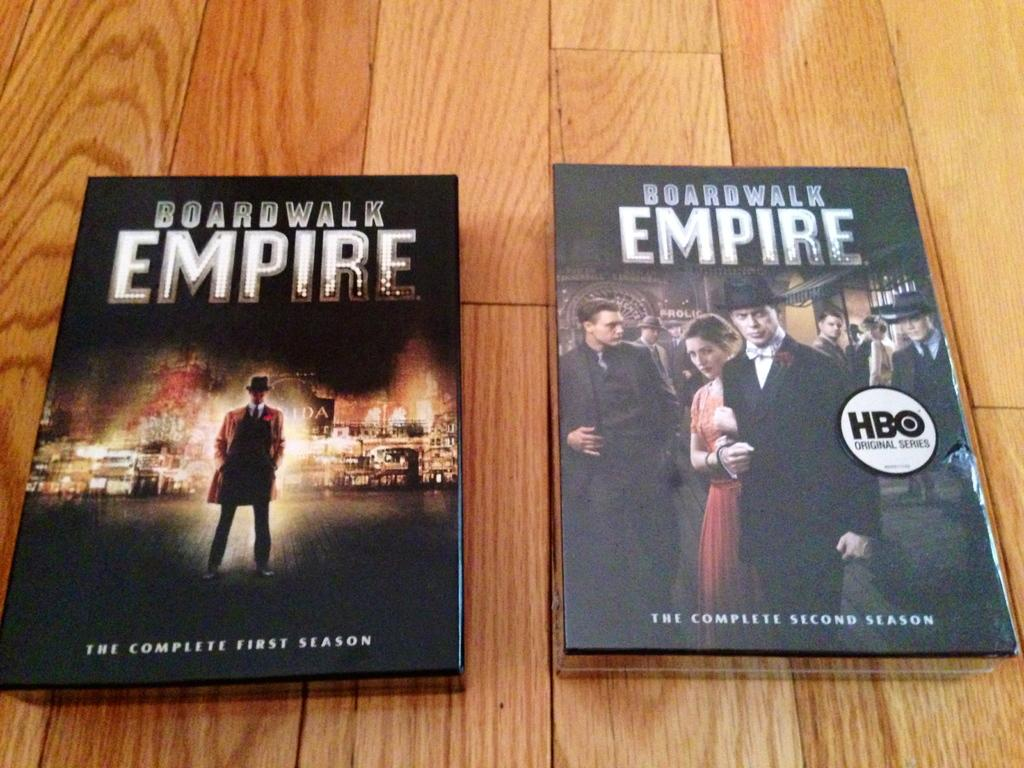<image>
Offer a succinct explanation of the picture presented. Case for Boardwalk Empire laying on the floor. 